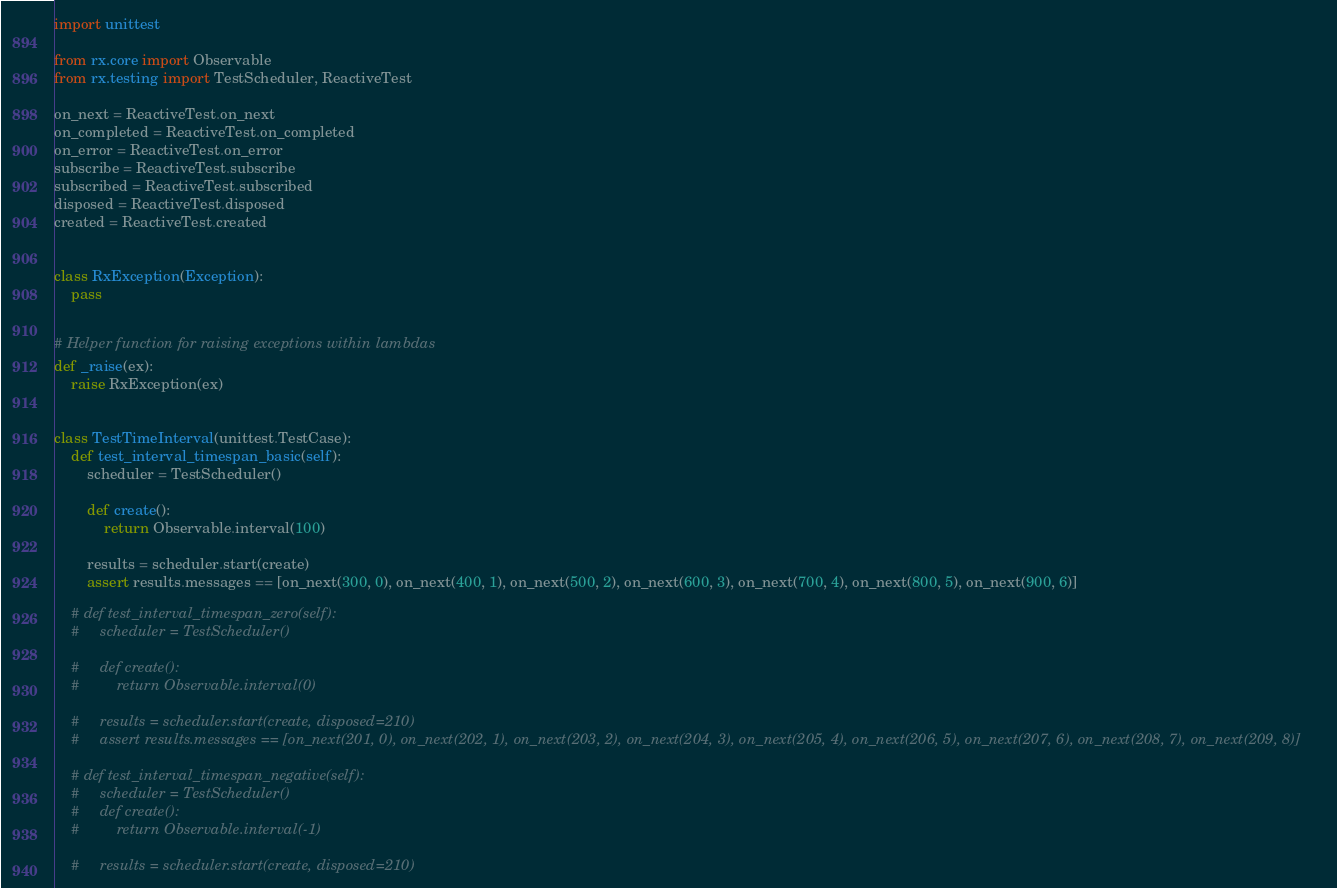<code> <loc_0><loc_0><loc_500><loc_500><_Python_>import unittest

from rx.core import Observable
from rx.testing import TestScheduler, ReactiveTest

on_next = ReactiveTest.on_next
on_completed = ReactiveTest.on_completed
on_error = ReactiveTest.on_error
subscribe = ReactiveTest.subscribe
subscribed = ReactiveTest.subscribed
disposed = ReactiveTest.disposed
created = ReactiveTest.created


class RxException(Exception):
    pass


# Helper function for raising exceptions within lambdas
def _raise(ex):
    raise RxException(ex)


class TestTimeInterval(unittest.TestCase):
    def test_interval_timespan_basic(self):
        scheduler = TestScheduler()

        def create():
            return Observable.interval(100)

        results = scheduler.start(create)
        assert results.messages == [on_next(300, 0), on_next(400, 1), on_next(500, 2), on_next(600, 3), on_next(700, 4), on_next(800, 5), on_next(900, 6)]

    # def test_interval_timespan_zero(self):
    #     scheduler = TestScheduler()

    #     def create():
    #         return Observable.interval(0)

    #     results = scheduler.start(create, disposed=210)
    #     assert results.messages == [on_next(201, 0), on_next(202, 1), on_next(203, 2), on_next(204, 3), on_next(205, 4), on_next(206, 5), on_next(207, 6), on_next(208, 7), on_next(209, 8)]

    # def test_interval_timespan_negative(self):
    #     scheduler = TestScheduler()
    #     def create():
    #         return Observable.interval(-1)

    #     results = scheduler.start(create, disposed=210)</code> 